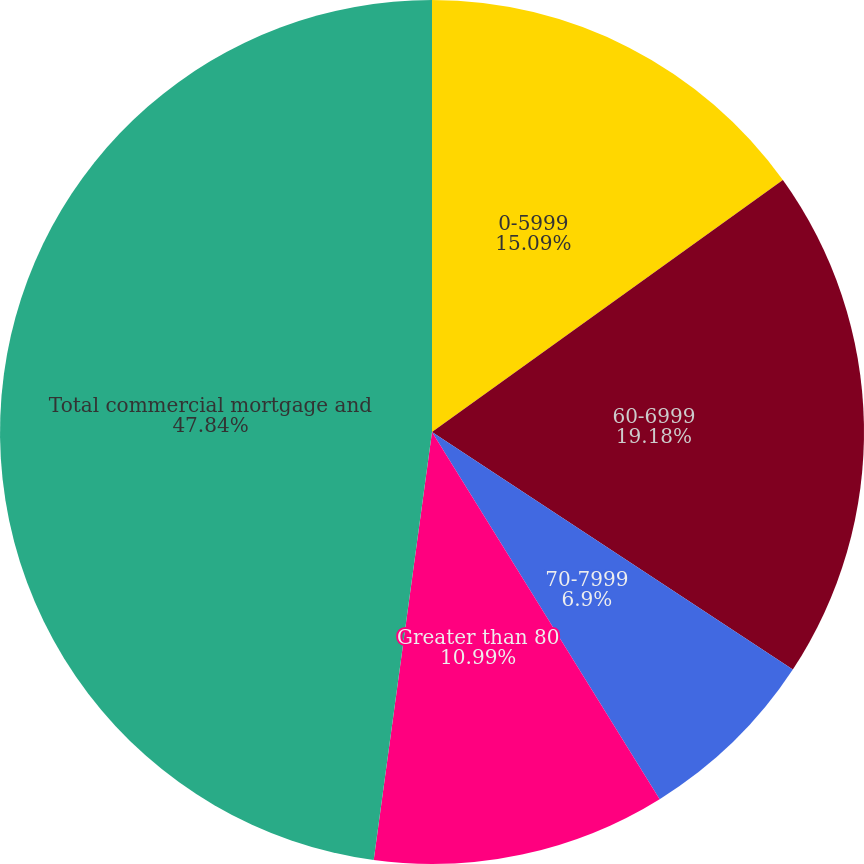<chart> <loc_0><loc_0><loc_500><loc_500><pie_chart><fcel>0-5999<fcel>60-6999<fcel>70-7999<fcel>Greater than 80<fcel>Total commercial mortgage and<nl><fcel>15.09%<fcel>19.18%<fcel>6.9%<fcel>10.99%<fcel>47.85%<nl></chart> 